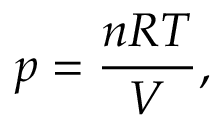<formula> <loc_0><loc_0><loc_500><loc_500>p = { \frac { n R T } { V } } ,</formula> 